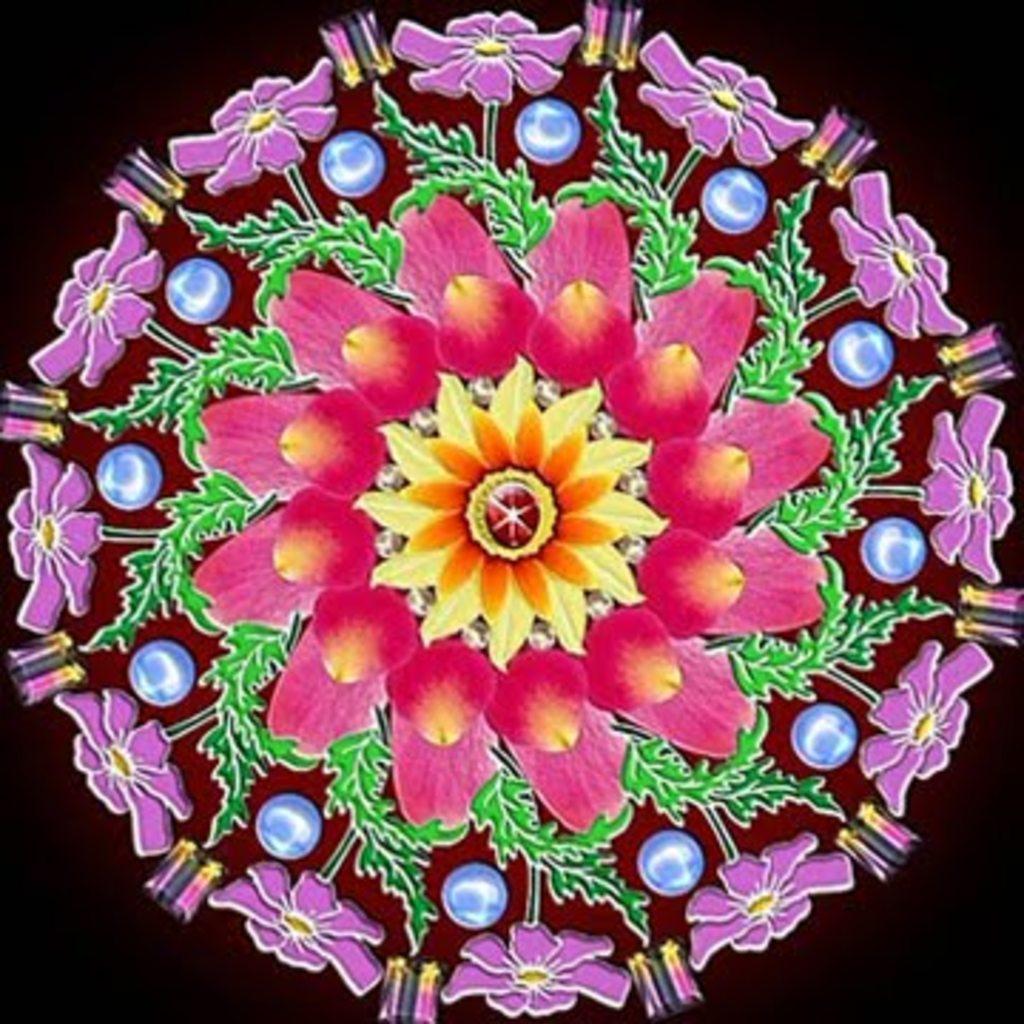Can you describe this image briefly? In the center of the image we can see some colorful design, in which we can see flowers and a few other objects. In the background, we can see it is blurred. 